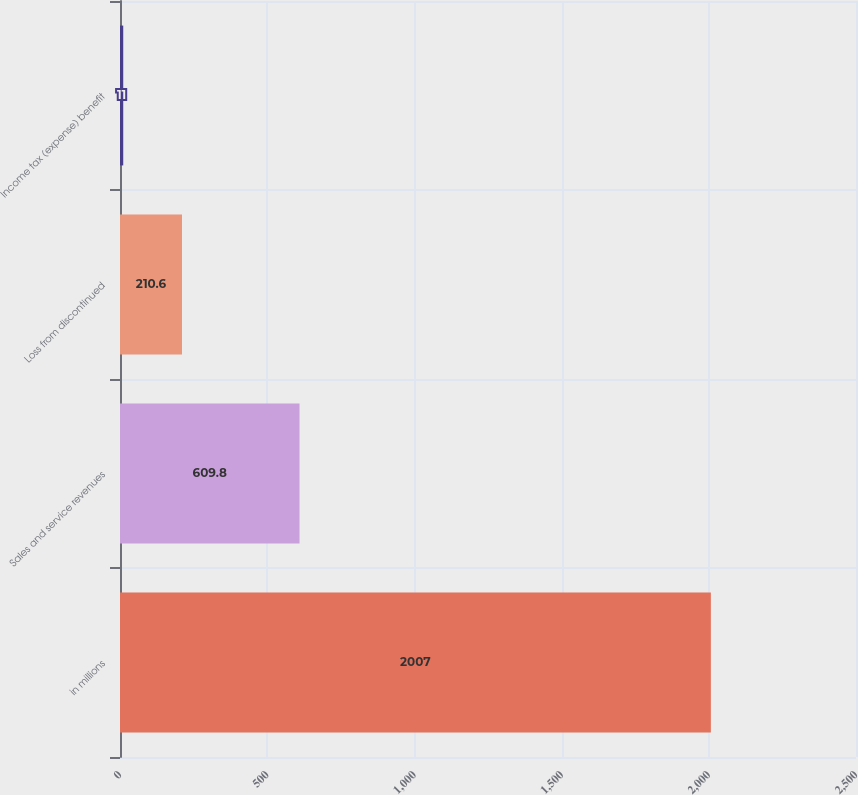Convert chart. <chart><loc_0><loc_0><loc_500><loc_500><bar_chart><fcel>in millions<fcel>Sales and service revenues<fcel>Loss from discontinued<fcel>Income tax (expense) benefit<nl><fcel>2007<fcel>609.8<fcel>210.6<fcel>11<nl></chart> 